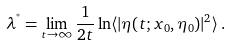Convert formula to latex. <formula><loc_0><loc_0><loc_500><loc_500>\lambda ^ { ^ { * } } = \lim _ { t \to \infty } \frac { 1 } { 2 t } \ln \langle | \eta ( t ; x _ { 0 } , \eta _ { 0 } ) | ^ { 2 } \rangle \, .</formula> 